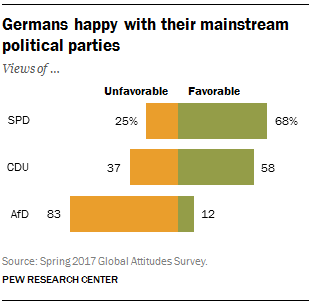Identify some key points in this picture. The SPD is the political party that is most favorable. The sum of all orange bars is less than the largest green bar. 